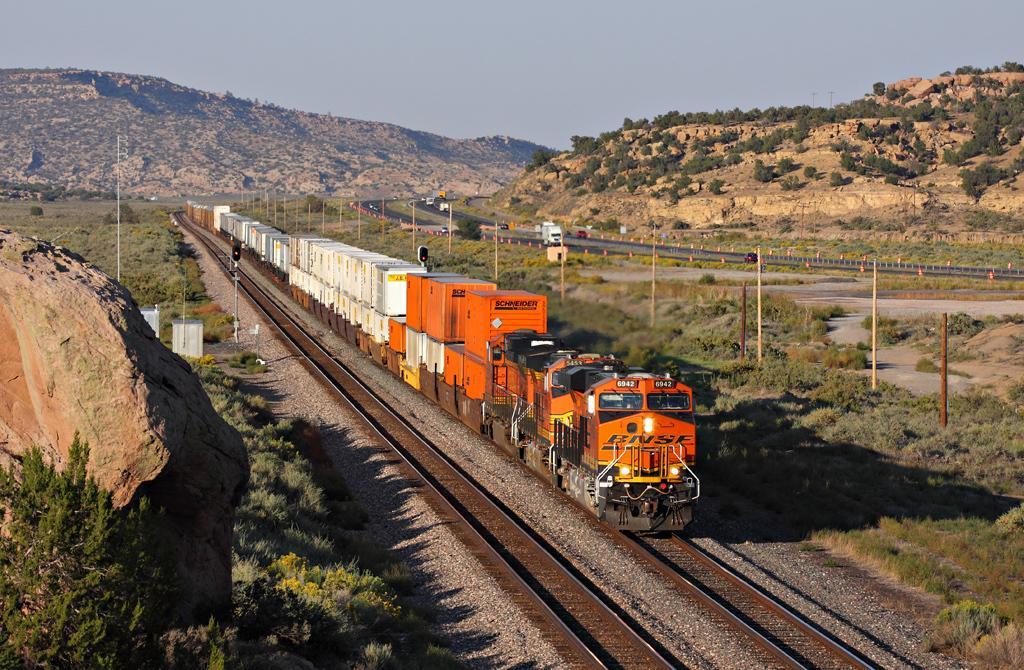In one or two sentences, can you explain what this image depicts? In this picture in the middle, we can see a train moving on the railway track. On the right side of the image, we can see few vehicles moving on the road, rocks, plants and poles. On the left side, we can see some stones, plants, poles, traffic signal, electrical box, trees. In the background, we can also see some rocks. On the top, we can see a sky, at the bottom there are some plants and stones on the railway track. 